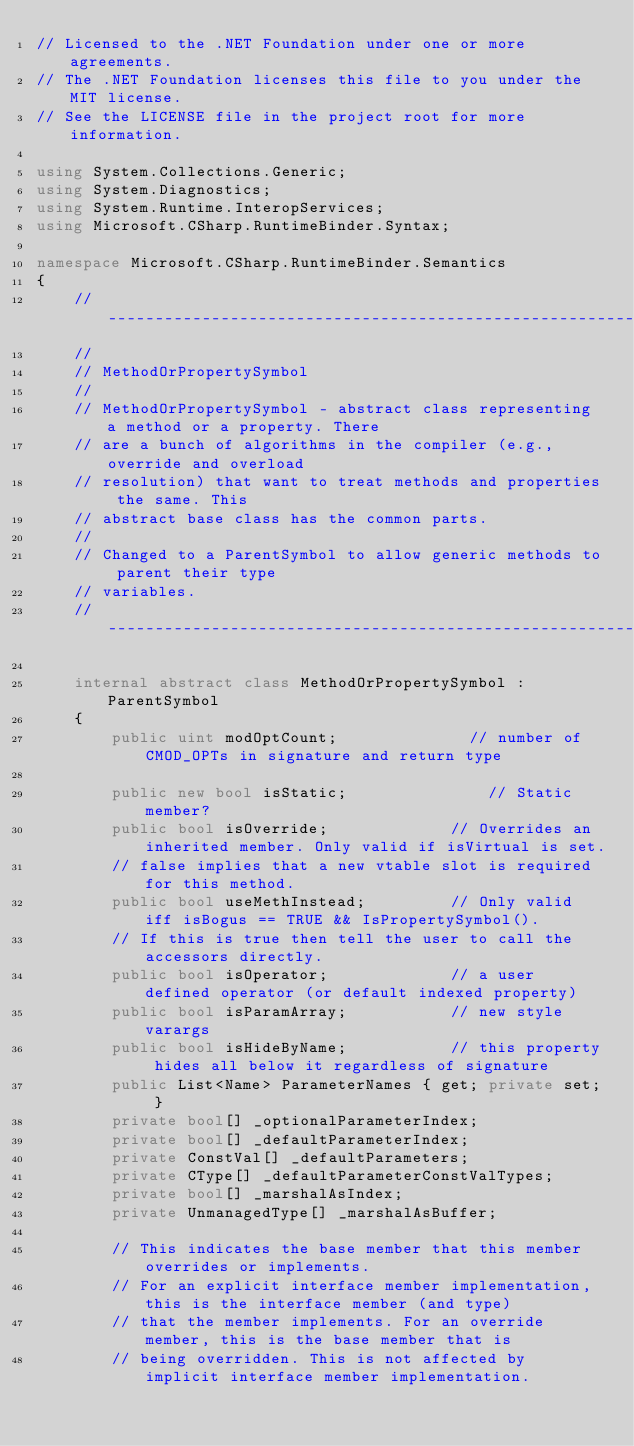<code> <loc_0><loc_0><loc_500><loc_500><_C#_>// Licensed to the .NET Foundation under one or more agreements.
// The .NET Foundation licenses this file to you under the MIT license.
// See the LICENSE file in the project root for more information.

using System.Collections.Generic;
using System.Diagnostics;
using System.Runtime.InteropServices;
using Microsoft.CSharp.RuntimeBinder.Syntax;

namespace Microsoft.CSharp.RuntimeBinder.Semantics
{
    // ----------------------------------------------------------------------------
    //
    // MethodOrPropertySymbol
    //
    // MethodOrPropertySymbol - abstract class representing a method or a property. There
    // are a bunch of algorithms in the compiler (e.g., override and overload 
    // resolution) that want to treat methods and properties the same. This 
    // abstract base class has the common parts. 
    //
    // Changed to a ParentSymbol to allow generic methods to parent their type
    // variables.
    // ----------------------------------------------------------------------------

    internal abstract class MethodOrPropertySymbol : ParentSymbol
    {
        public uint modOptCount;              // number of CMOD_OPTs in signature and return type

        public new bool isStatic;               // Static member?
        public bool isOverride;             // Overrides an inherited member. Only valid if isVirtual is set.
        // false implies that a new vtable slot is required for this method.
        public bool useMethInstead;         // Only valid iff isBogus == TRUE && IsPropertySymbol().
        // If this is true then tell the user to call the accessors directly.
        public bool isOperator;             // a user defined operator (or default indexed property)
        public bool isParamArray;           // new style varargs
        public bool isHideByName;           // this property hides all below it regardless of signature
        public List<Name> ParameterNames { get; private set; }
        private bool[] _optionalParameterIndex;
        private bool[] _defaultParameterIndex;
        private ConstVal[] _defaultParameters;
        private CType[] _defaultParameterConstValTypes;
        private bool[] _marshalAsIndex;
        private UnmanagedType[] _marshalAsBuffer;

        // This indicates the base member that this member overrides or implements.
        // For an explicit interface member implementation, this is the interface member (and type)
        // that the member implements. For an override member, this is the base member that is
        // being overridden. This is not affected by implicit interface member implementation.</code> 